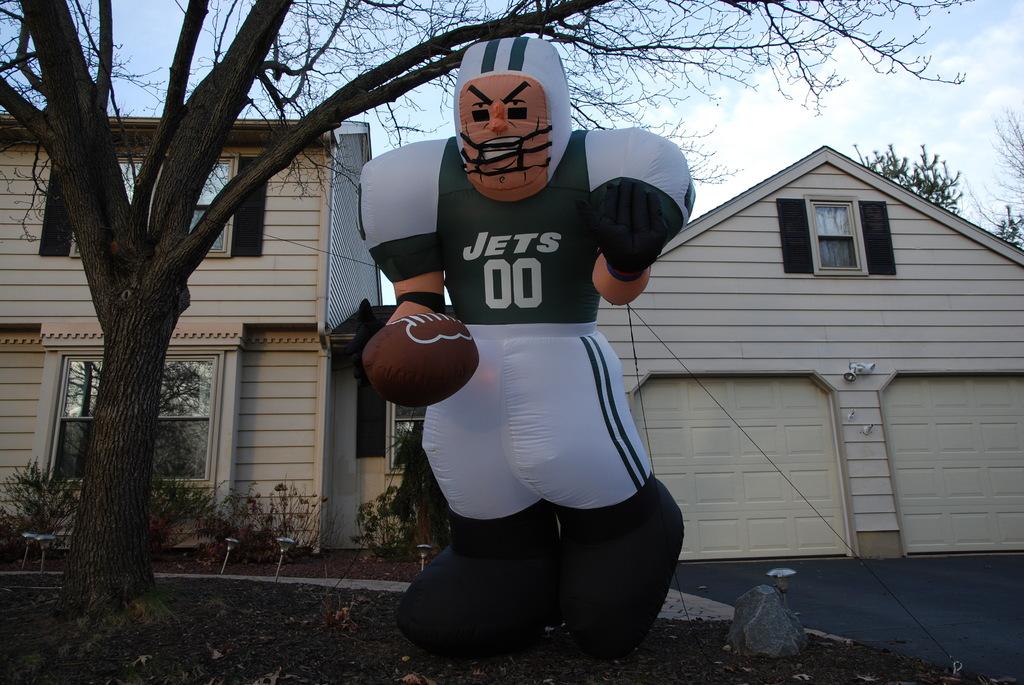What team is on the balloon man's shirt?
Offer a very short reply. Jets. What is the jersey number?
Your response must be concise. 00. 